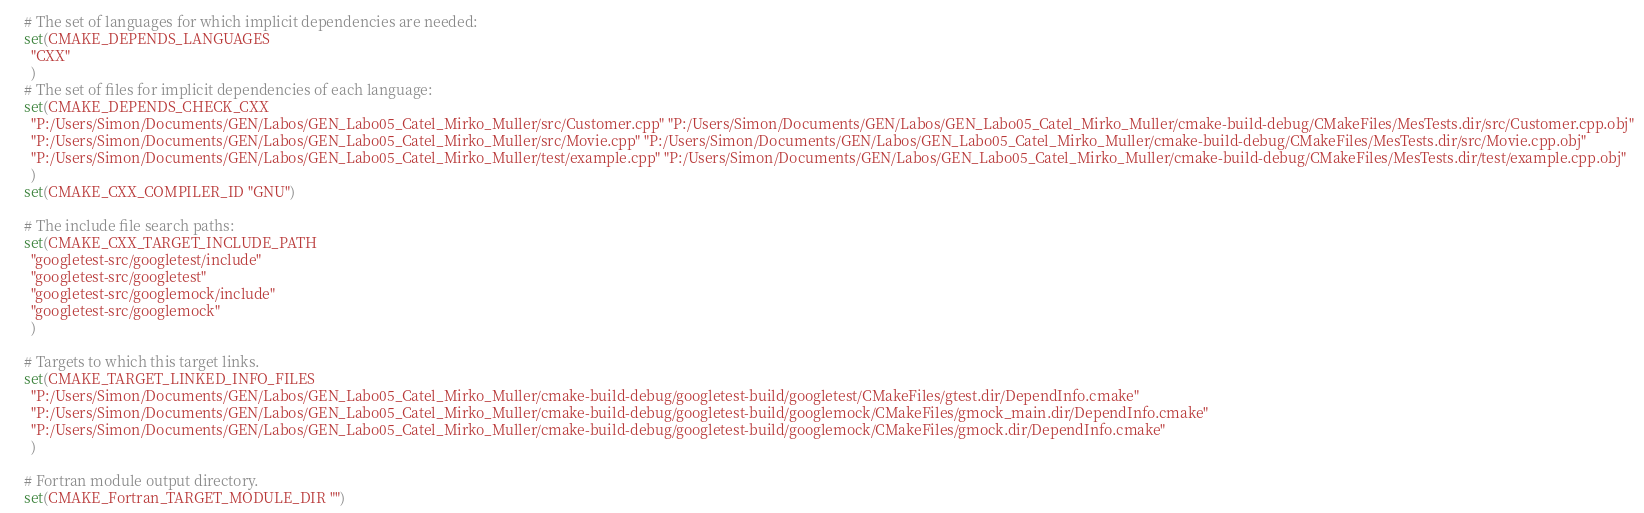<code> <loc_0><loc_0><loc_500><loc_500><_CMake_># The set of languages for which implicit dependencies are needed:
set(CMAKE_DEPENDS_LANGUAGES
  "CXX"
  )
# The set of files for implicit dependencies of each language:
set(CMAKE_DEPENDS_CHECK_CXX
  "P:/Users/Simon/Documents/GEN/Labos/GEN_Labo05_Catel_Mirko_Muller/src/Customer.cpp" "P:/Users/Simon/Documents/GEN/Labos/GEN_Labo05_Catel_Mirko_Muller/cmake-build-debug/CMakeFiles/MesTests.dir/src/Customer.cpp.obj"
  "P:/Users/Simon/Documents/GEN/Labos/GEN_Labo05_Catel_Mirko_Muller/src/Movie.cpp" "P:/Users/Simon/Documents/GEN/Labos/GEN_Labo05_Catel_Mirko_Muller/cmake-build-debug/CMakeFiles/MesTests.dir/src/Movie.cpp.obj"
  "P:/Users/Simon/Documents/GEN/Labos/GEN_Labo05_Catel_Mirko_Muller/test/example.cpp" "P:/Users/Simon/Documents/GEN/Labos/GEN_Labo05_Catel_Mirko_Muller/cmake-build-debug/CMakeFiles/MesTests.dir/test/example.cpp.obj"
  )
set(CMAKE_CXX_COMPILER_ID "GNU")

# The include file search paths:
set(CMAKE_CXX_TARGET_INCLUDE_PATH
  "googletest-src/googletest/include"
  "googletest-src/googletest"
  "googletest-src/googlemock/include"
  "googletest-src/googlemock"
  )

# Targets to which this target links.
set(CMAKE_TARGET_LINKED_INFO_FILES
  "P:/Users/Simon/Documents/GEN/Labos/GEN_Labo05_Catel_Mirko_Muller/cmake-build-debug/googletest-build/googletest/CMakeFiles/gtest.dir/DependInfo.cmake"
  "P:/Users/Simon/Documents/GEN/Labos/GEN_Labo05_Catel_Mirko_Muller/cmake-build-debug/googletest-build/googlemock/CMakeFiles/gmock_main.dir/DependInfo.cmake"
  "P:/Users/Simon/Documents/GEN/Labos/GEN_Labo05_Catel_Mirko_Muller/cmake-build-debug/googletest-build/googlemock/CMakeFiles/gmock.dir/DependInfo.cmake"
  )

# Fortran module output directory.
set(CMAKE_Fortran_TARGET_MODULE_DIR "")
</code> 